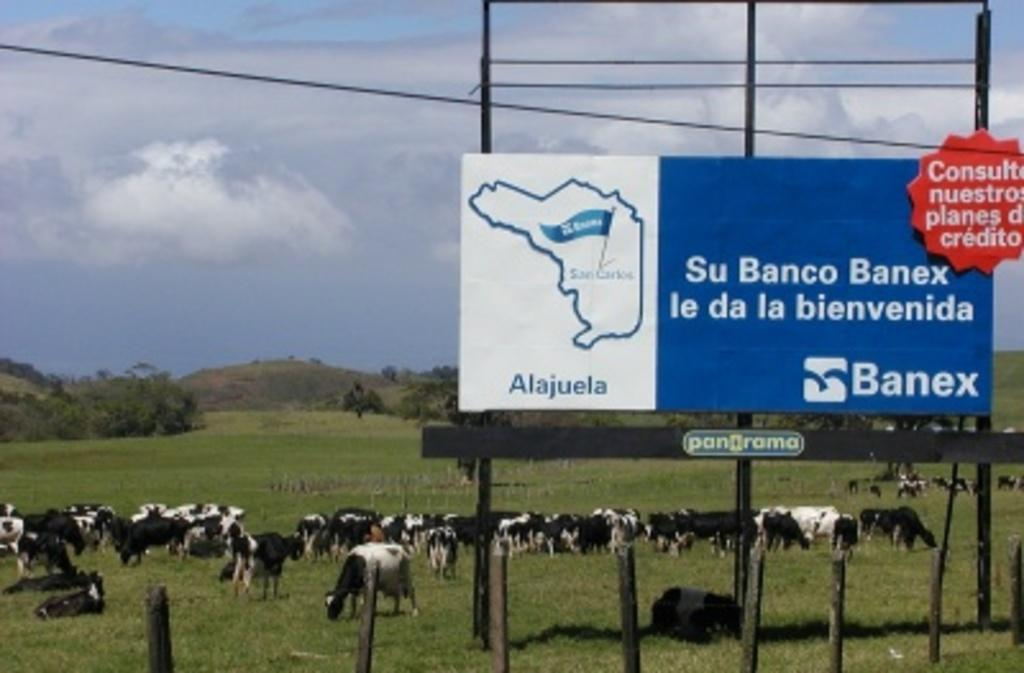What is the main structure visible in the image? There is a hoarding in the image. What is the hoarding supported by? The hoarding is supported by poles, which are also visible in the image. What is connected to the poles? There is a board on poles in the image. What else can be seen in the image? There is a wire, an object on the grass, animals, trees in the background, a hill in the background, sky visible in the background, and clouds in the sky. What type of education is being exchanged between the cats in the image? There are no cats present in the image, so no education exchange can be observed. 